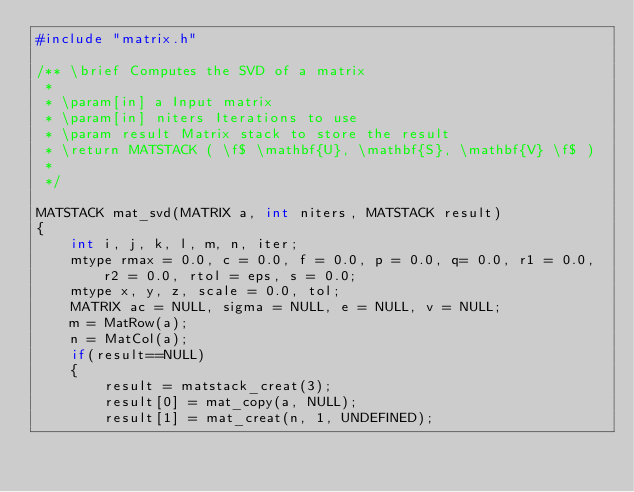<code> <loc_0><loc_0><loc_500><loc_500><_C_>#include "matrix.h"

/** \brief Computes the SVD of a matrix
 *
 * \param[in] a Input matrix
 * \param[in] niters Iterations to use
 * \param result Matrix stack to store the result
 * \return MATSTACK ( \f$ \mathbf{U}, \mathbf{S}, \mathbf{V} \f$ )
 *
 */

MATSTACK mat_svd(MATRIX a, int niters, MATSTACK result)
{
    int i, j, k, l, m, n, iter;
    mtype rmax = 0.0, c = 0.0, f = 0.0, p = 0.0, q= 0.0, r1 = 0.0, r2 = 0.0, rtol = eps, s = 0.0;
    mtype x, y, z, scale = 0.0, tol;
    MATRIX ac = NULL, sigma = NULL, e = NULL, v = NULL;
    m = MatRow(a);
    n = MatCol(a);
    if(result==NULL)
    {
        result = matstack_creat(3);
        result[0] = mat_copy(a, NULL);
        result[1] = mat_creat(n, 1, UNDEFINED);</code> 